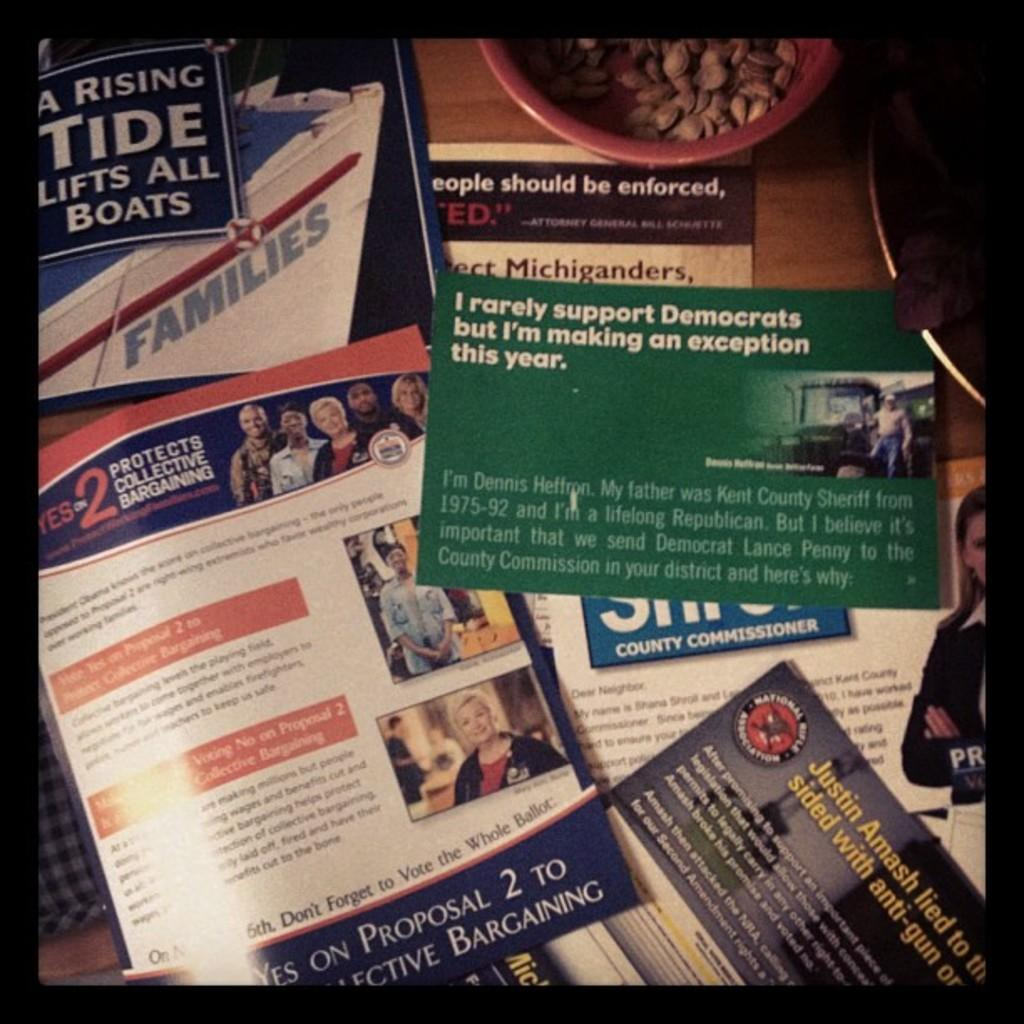What is present on the papers in the image? There are papers with information in the image. What other objects are visible near the papers? There are nuts beside the papers in the image. What type of dress is being worn by the society in the image? There is no society or dress present in the image; it only features papers with information and nuts. 